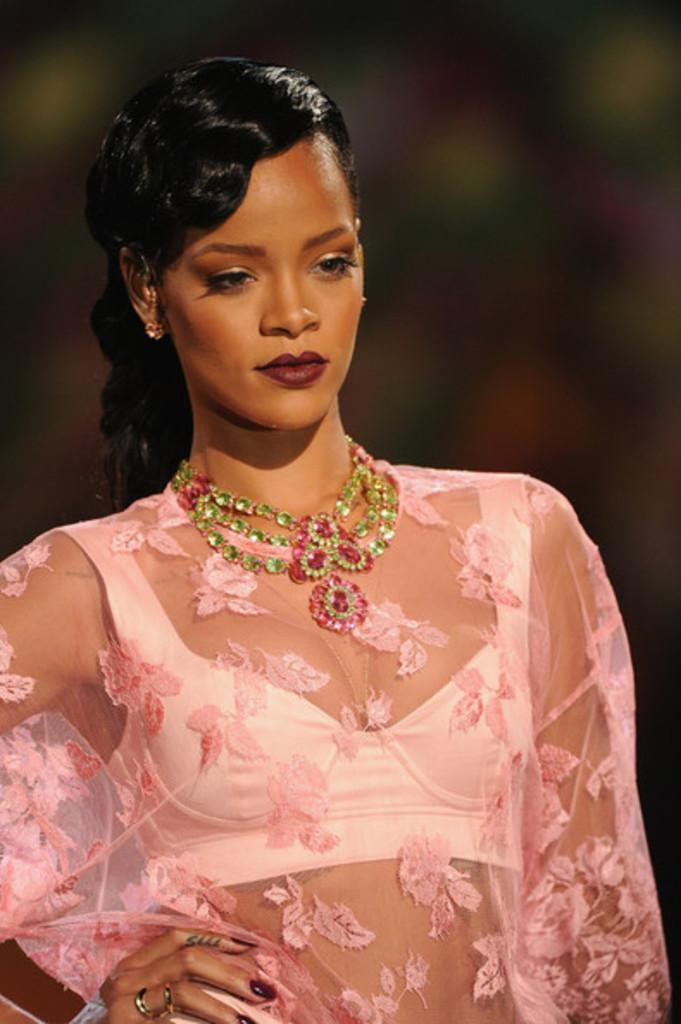Who is present in the image? There is a woman in the image. What type of volcano can be seen erupting in the background of the image? There is no volcano present in the image; it only features a woman. What type of desk is the woman sitting at in the image? There is no desk present in the image; it only features a woman. 